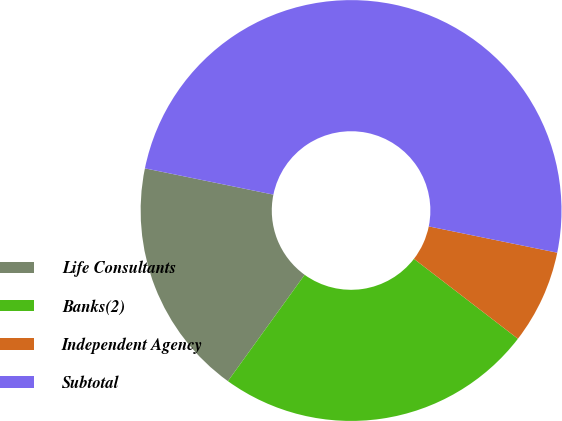Convert chart to OTSL. <chart><loc_0><loc_0><loc_500><loc_500><pie_chart><fcel>Life Consultants<fcel>Banks(2)<fcel>Independent Agency<fcel>Subtotal<nl><fcel>18.26%<fcel>24.52%<fcel>7.22%<fcel>50.0%<nl></chart> 